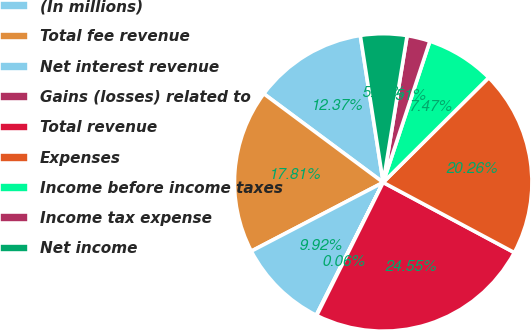Convert chart to OTSL. <chart><loc_0><loc_0><loc_500><loc_500><pie_chart><fcel>(In millions)<fcel>Total fee revenue<fcel>Net interest revenue<fcel>Gains (losses) related to<fcel>Total revenue<fcel>Expenses<fcel>Income before income taxes<fcel>Income tax expense<fcel>Net income<nl><fcel>12.37%<fcel>17.81%<fcel>9.92%<fcel>0.06%<fcel>24.55%<fcel>20.26%<fcel>7.47%<fcel>2.51%<fcel>5.03%<nl></chart> 